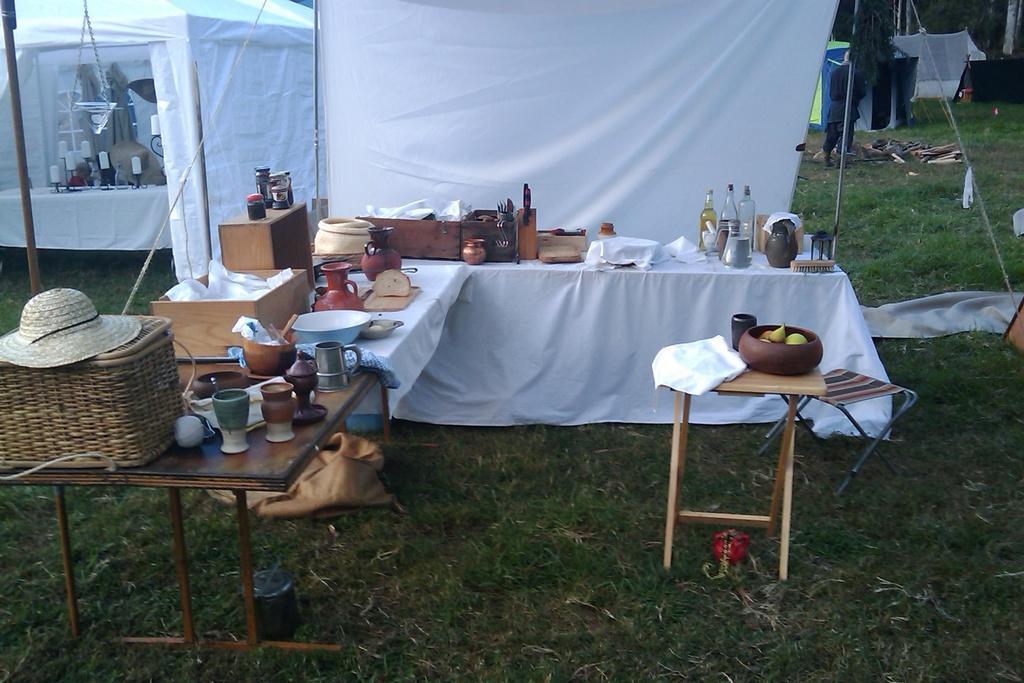Could you give a brief overview of what you see in this image? There is a, glass, bottle, cloth other objects are present on the table. This is tent, these is grass and a stool. 